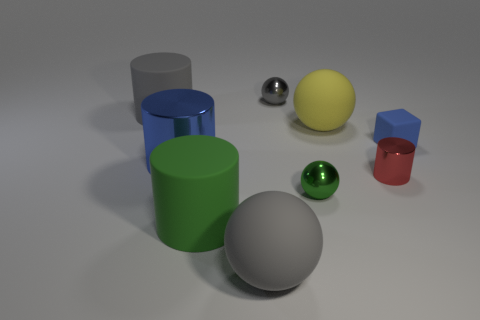Add 1 gray balls. How many objects exist? 10 Subtract all balls. How many objects are left? 5 Add 1 large gray matte cylinders. How many large gray matte cylinders exist? 2 Subtract 0 cyan blocks. How many objects are left? 9 Subtract all big gray balls. Subtract all tiny red cylinders. How many objects are left? 7 Add 7 large cylinders. How many large cylinders are left? 10 